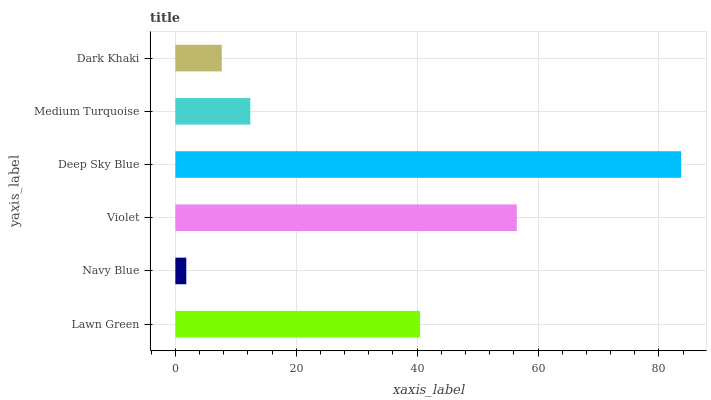Is Navy Blue the minimum?
Answer yes or no. Yes. Is Deep Sky Blue the maximum?
Answer yes or no. Yes. Is Violet the minimum?
Answer yes or no. No. Is Violet the maximum?
Answer yes or no. No. Is Violet greater than Navy Blue?
Answer yes or no. Yes. Is Navy Blue less than Violet?
Answer yes or no. Yes. Is Navy Blue greater than Violet?
Answer yes or no. No. Is Violet less than Navy Blue?
Answer yes or no. No. Is Lawn Green the high median?
Answer yes or no. Yes. Is Medium Turquoise the low median?
Answer yes or no. Yes. Is Violet the high median?
Answer yes or no. No. Is Navy Blue the low median?
Answer yes or no. No. 